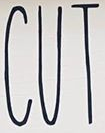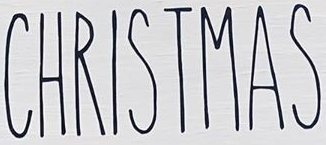What words are shown in these images in order, separated by a semicolon? CUT; CHRISTMAS 